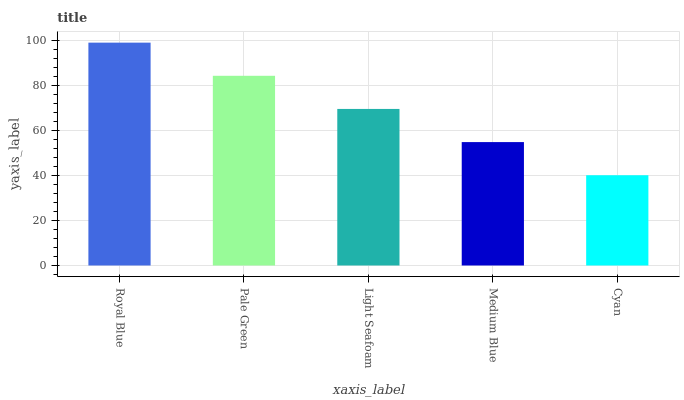Is Cyan the minimum?
Answer yes or no. Yes. Is Royal Blue the maximum?
Answer yes or no. Yes. Is Pale Green the minimum?
Answer yes or no. No. Is Pale Green the maximum?
Answer yes or no. No. Is Royal Blue greater than Pale Green?
Answer yes or no. Yes. Is Pale Green less than Royal Blue?
Answer yes or no. Yes. Is Pale Green greater than Royal Blue?
Answer yes or no. No. Is Royal Blue less than Pale Green?
Answer yes or no. No. Is Light Seafoam the high median?
Answer yes or no. Yes. Is Light Seafoam the low median?
Answer yes or no. Yes. Is Royal Blue the high median?
Answer yes or no. No. Is Pale Green the low median?
Answer yes or no. No. 